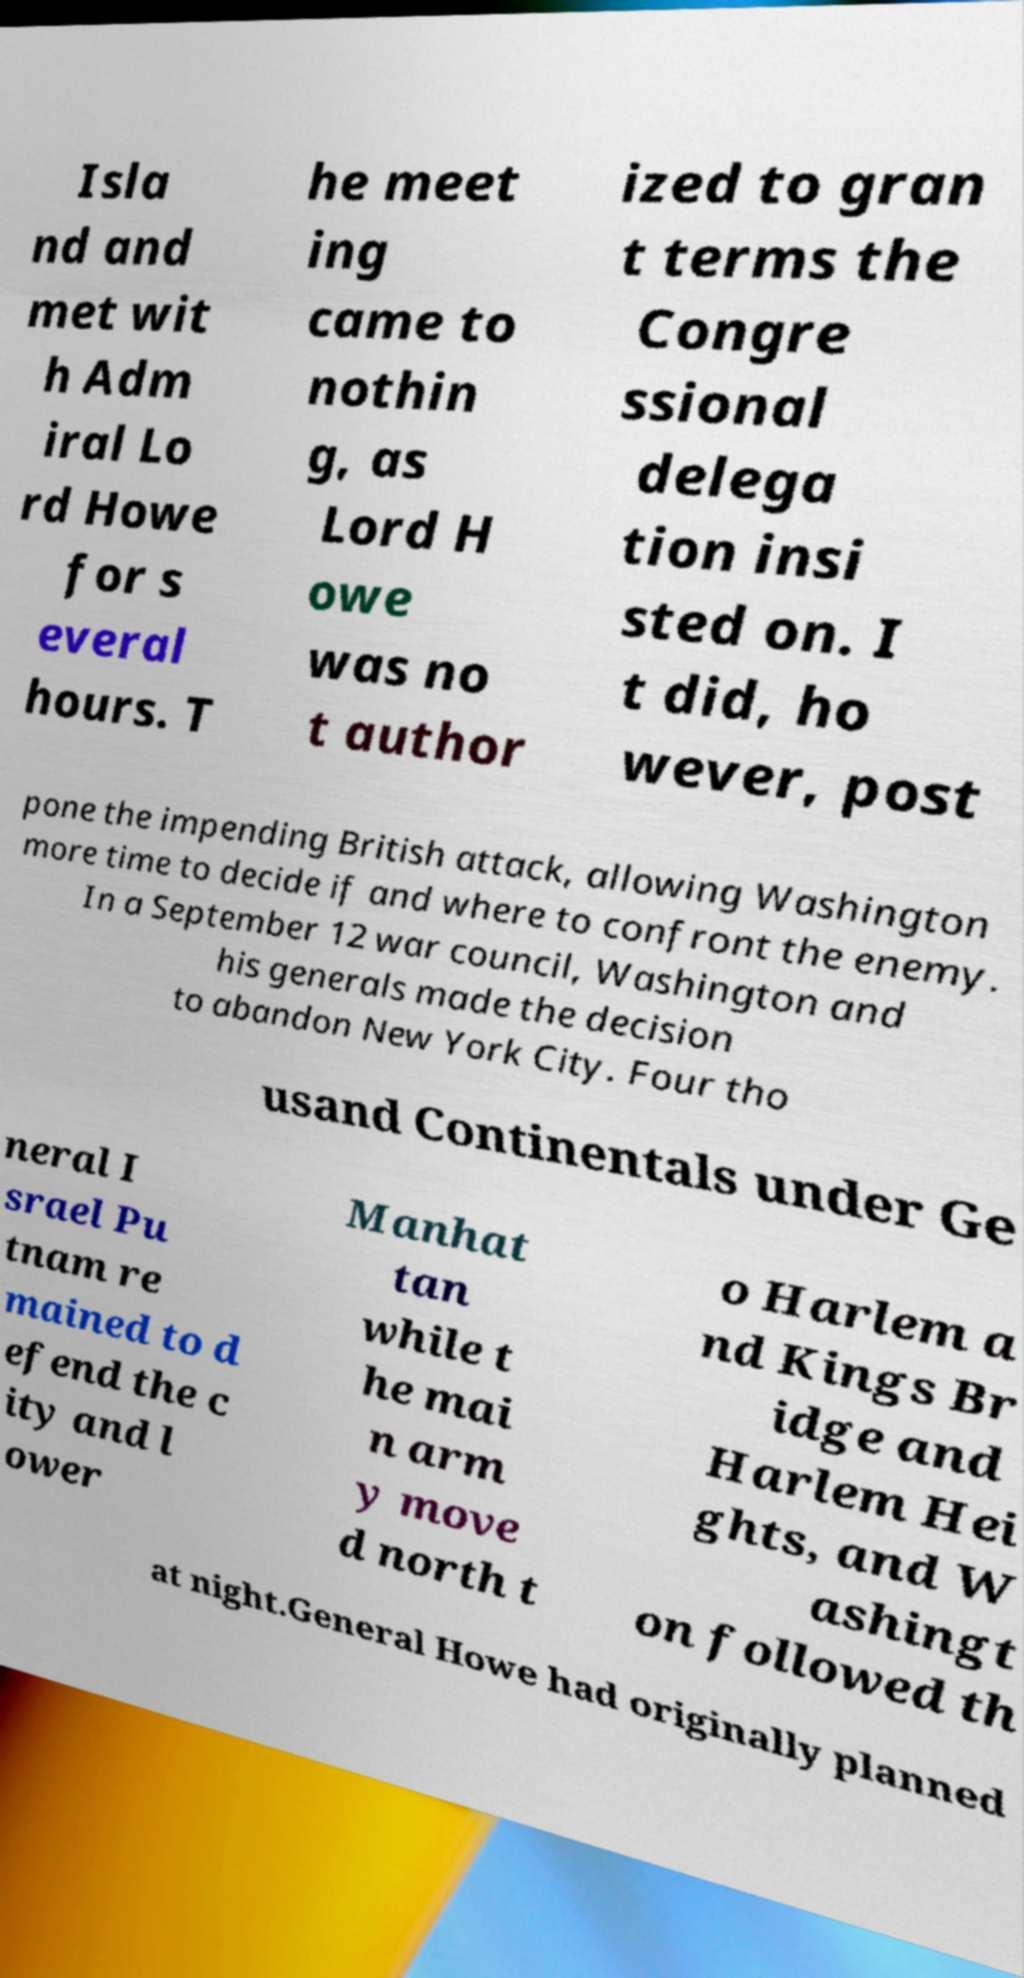Can you read and provide the text displayed in the image?This photo seems to have some interesting text. Can you extract and type it out for me? Isla nd and met wit h Adm iral Lo rd Howe for s everal hours. T he meet ing came to nothin g, as Lord H owe was no t author ized to gran t terms the Congre ssional delega tion insi sted on. I t did, ho wever, post pone the impending British attack, allowing Washington more time to decide if and where to confront the enemy. In a September 12 war council, Washington and his generals made the decision to abandon New York City. Four tho usand Continentals under Ge neral I srael Pu tnam re mained to d efend the c ity and l ower Manhat tan while t he mai n arm y move d north t o Harlem a nd Kings Br idge and Harlem Hei ghts, and W ashingt on followed th at night.General Howe had originally planned 